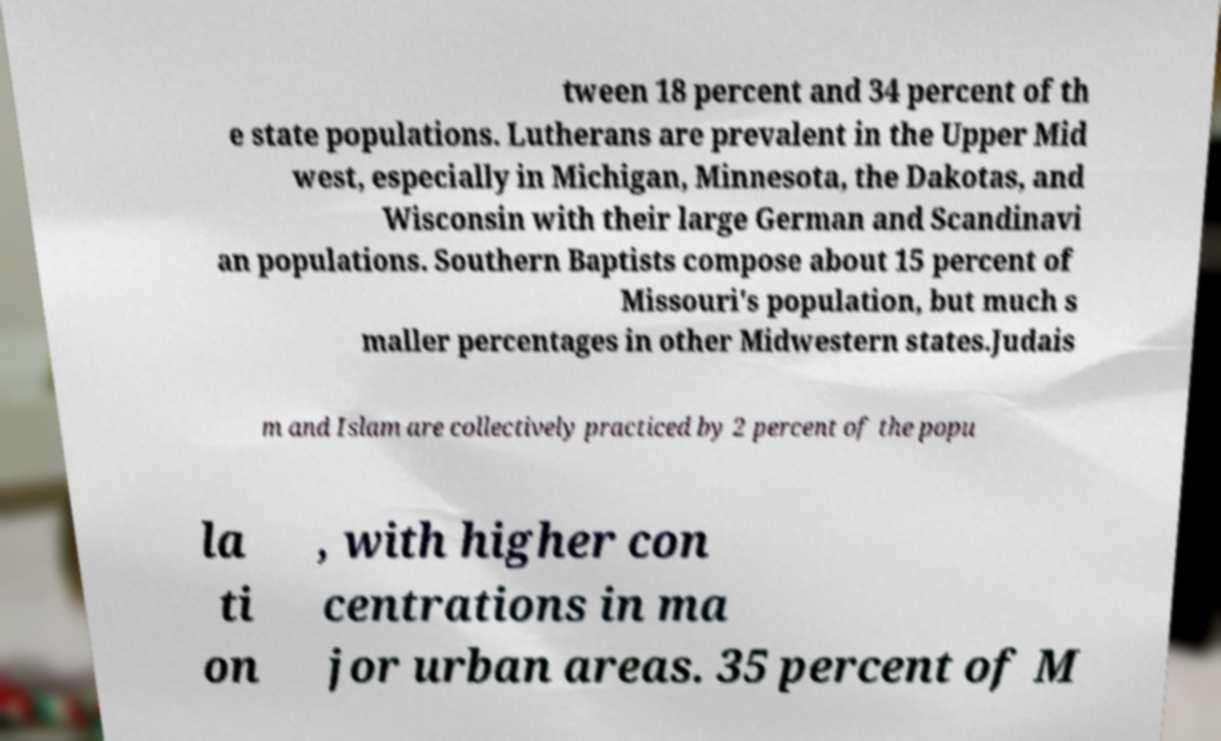Can you accurately transcribe the text from the provided image for me? tween 18 percent and 34 percent of th e state populations. Lutherans are prevalent in the Upper Mid west, especially in Michigan, Minnesota, the Dakotas, and Wisconsin with their large German and Scandinavi an populations. Southern Baptists compose about 15 percent of Missouri's population, but much s maller percentages in other Midwestern states.Judais m and Islam are collectively practiced by 2 percent of the popu la ti on , with higher con centrations in ma jor urban areas. 35 percent of M 